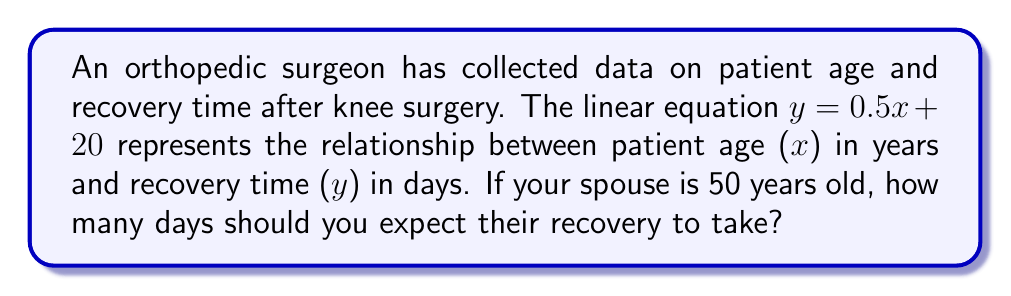What is the answer to this math problem? To solve this problem, we'll follow these steps:

1. Identify the given information:
   - The linear equation is $y = 0.5x + 20$
   - y represents recovery time in days
   - x represents patient age in years
   - Your spouse's age is 50 years

2. Substitute the known value (x = 50) into the equation:
   $y = 0.5(50) + 20$

3. Solve the equation:
   $y = 25 + 20$
   $y = 45$

Therefore, based on the given linear relationship, you should expect your 50-year-old spouse's recovery to take 45 days.

Note: This linear model suggests that for every year increase in age, the recovery time increases by 0.5 days, with a base recovery time of 20 days for a theoretical patient of age 0.
Answer: 45 days 